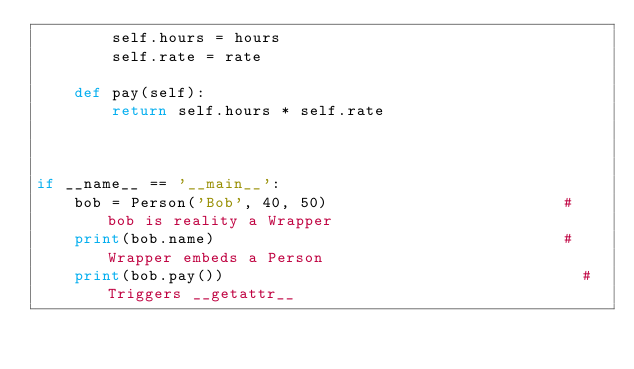Convert code to text. <code><loc_0><loc_0><loc_500><loc_500><_Python_>        self.hours = hours
        self.rate = rate

    def pay(self):
        return self.hours * self.rate



if __name__ == '__main__':
    bob = Person('Bob', 40, 50)                         # bob is reality a Wrapper
    print(bob.name)                                     # Wrapper embeds a Person
    print(bob.pay())                                      # Triggers __getattr__
</code> 